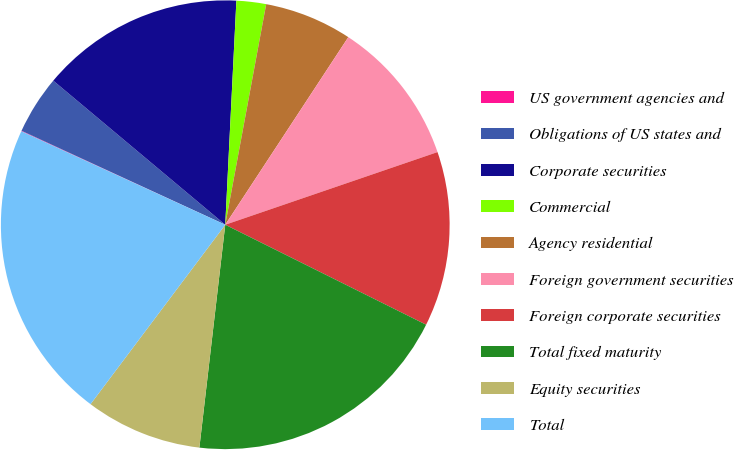Convert chart. <chart><loc_0><loc_0><loc_500><loc_500><pie_chart><fcel>US government agencies and<fcel>Obligations of US states and<fcel>Corporate securities<fcel>Commercial<fcel>Agency residential<fcel>Foreign government securities<fcel>Foreign corporate securities<fcel>Total fixed maturity<fcel>Equity securities<fcel>Total<nl><fcel>0.04%<fcel>4.22%<fcel>14.69%<fcel>2.13%<fcel>6.32%<fcel>10.51%<fcel>12.6%<fcel>19.49%<fcel>8.41%<fcel>21.59%<nl></chart> 